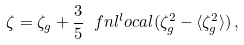Convert formula to latex. <formula><loc_0><loc_0><loc_500><loc_500>\zeta = \zeta _ { g } + \frac { 3 } { 5 } \ f n l ^ { l } o c a l ( \zeta _ { g } ^ { 2 } - \langle \zeta _ { g } ^ { 2 } \rangle ) \, ,</formula> 